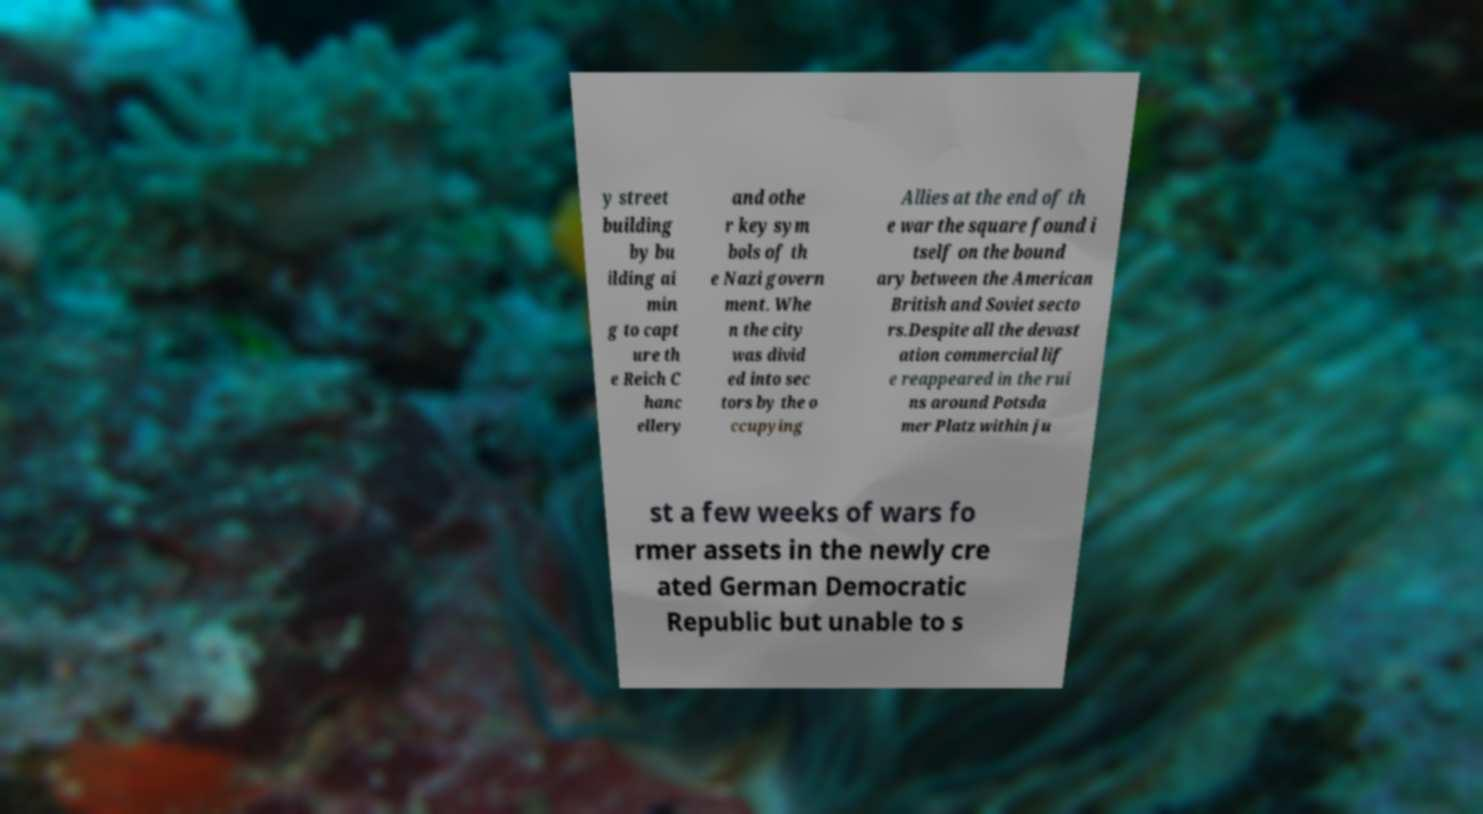Can you accurately transcribe the text from the provided image for me? y street building by bu ilding ai min g to capt ure th e Reich C hanc ellery and othe r key sym bols of th e Nazi govern ment. Whe n the city was divid ed into sec tors by the o ccupying Allies at the end of th e war the square found i tself on the bound ary between the American British and Soviet secto rs.Despite all the devast ation commercial lif e reappeared in the rui ns around Potsda mer Platz within ju st a few weeks of wars fo rmer assets in the newly cre ated German Democratic Republic but unable to s 